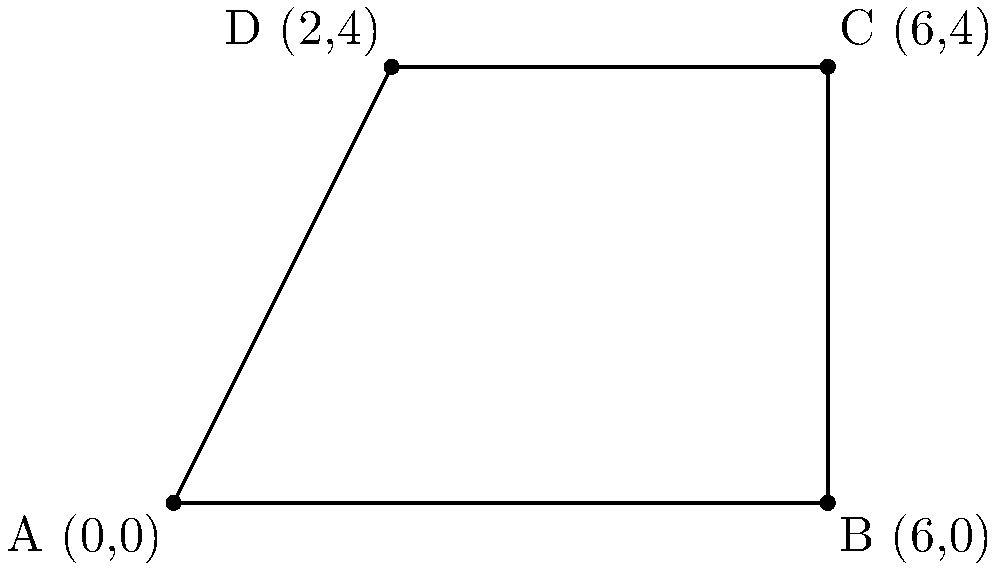A humanitarian organization is planning to set up a rectangular refugee camp. The coordinates of the camp's corners are A(0,0), B(6,0), C(6,4), and D(2,4) on a coordinate plane where each unit represents 100 meters. Calculate the area of the refugee camp in square meters. To calculate the area of the rectangular refugee camp, we'll follow these steps:

1) Identify the length and width of the rectangle:
   - Length: x-coordinate difference between B and A
     $6 - 0 = 6$ units
   - Width: y-coordinate difference between C and B
     $4 - 0 = 4$ units

2) Calculate the area in square units:
   Area = length × width
   $A = 6 × 4 = 24$ square units

3) Convert square units to square meters:
   Each unit represents 100 meters, so each square unit is 100m × 100m = 10,000 m²
   
   Total area in m² = 24 × 10,000 = 240,000 m²

Therefore, the area of the refugee camp is 240,000 square meters.
Answer: 240,000 m² 